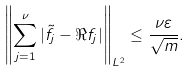Convert formula to latex. <formula><loc_0><loc_0><loc_500><loc_500>\left \| \sum _ { j = 1 } ^ { \nu } | \tilde { f } _ { j } - \Re f _ { j } | \right \| _ { L ^ { 2 } } \leq \frac { \nu \varepsilon } { \sqrt { m } } .</formula> 